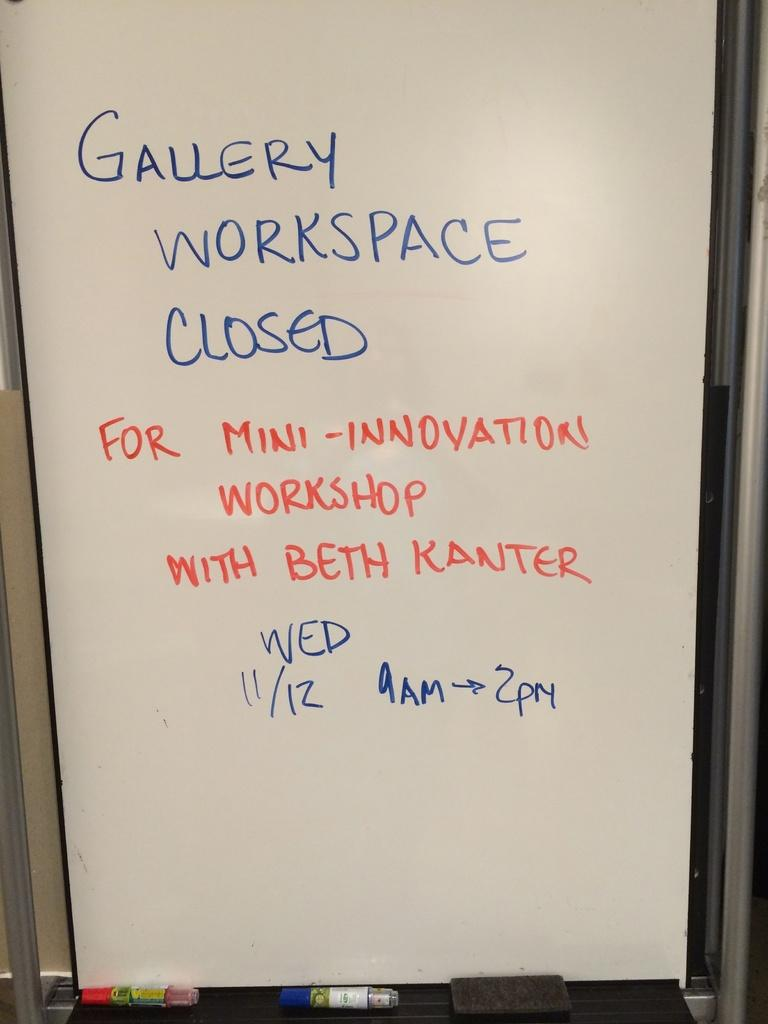<image>
Create a compact narrative representing the image presented. White board that says "Gallery Workspace Closed" in blue. 